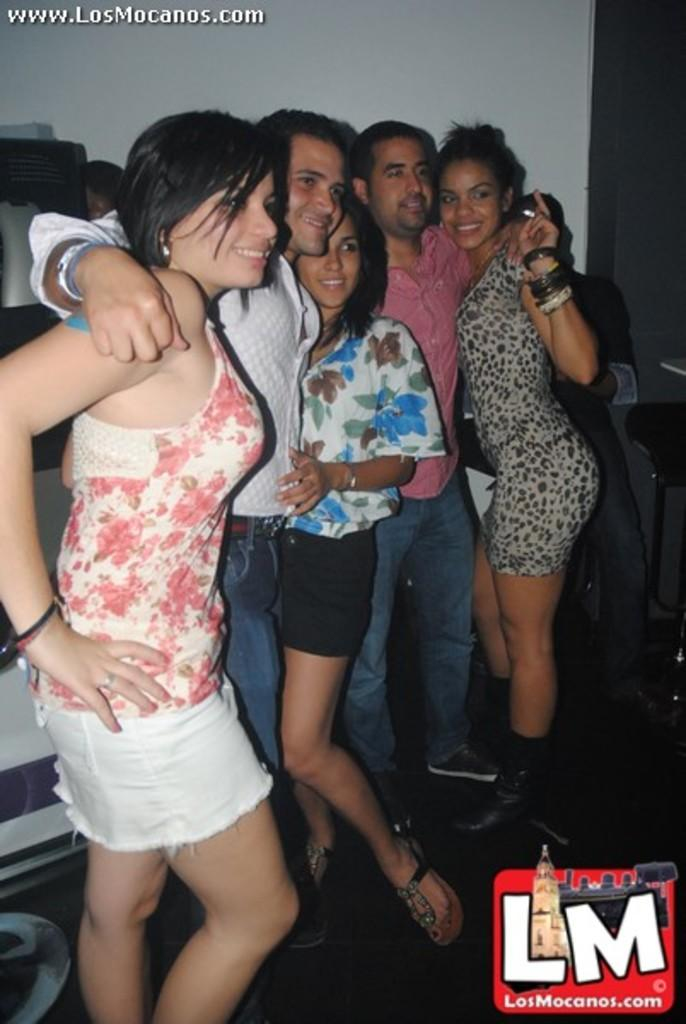Who or what can be seen in the image? There are people in the image. What type of furniture is present in the image? There is a chair in the image. What is the background of the image made up of? There is a wall visible in the image. Is there any text or writing in the image? Yes, there is text on the image. How much does the dog weigh in the image? There is no dog present in the image, so its weight cannot be determined. 